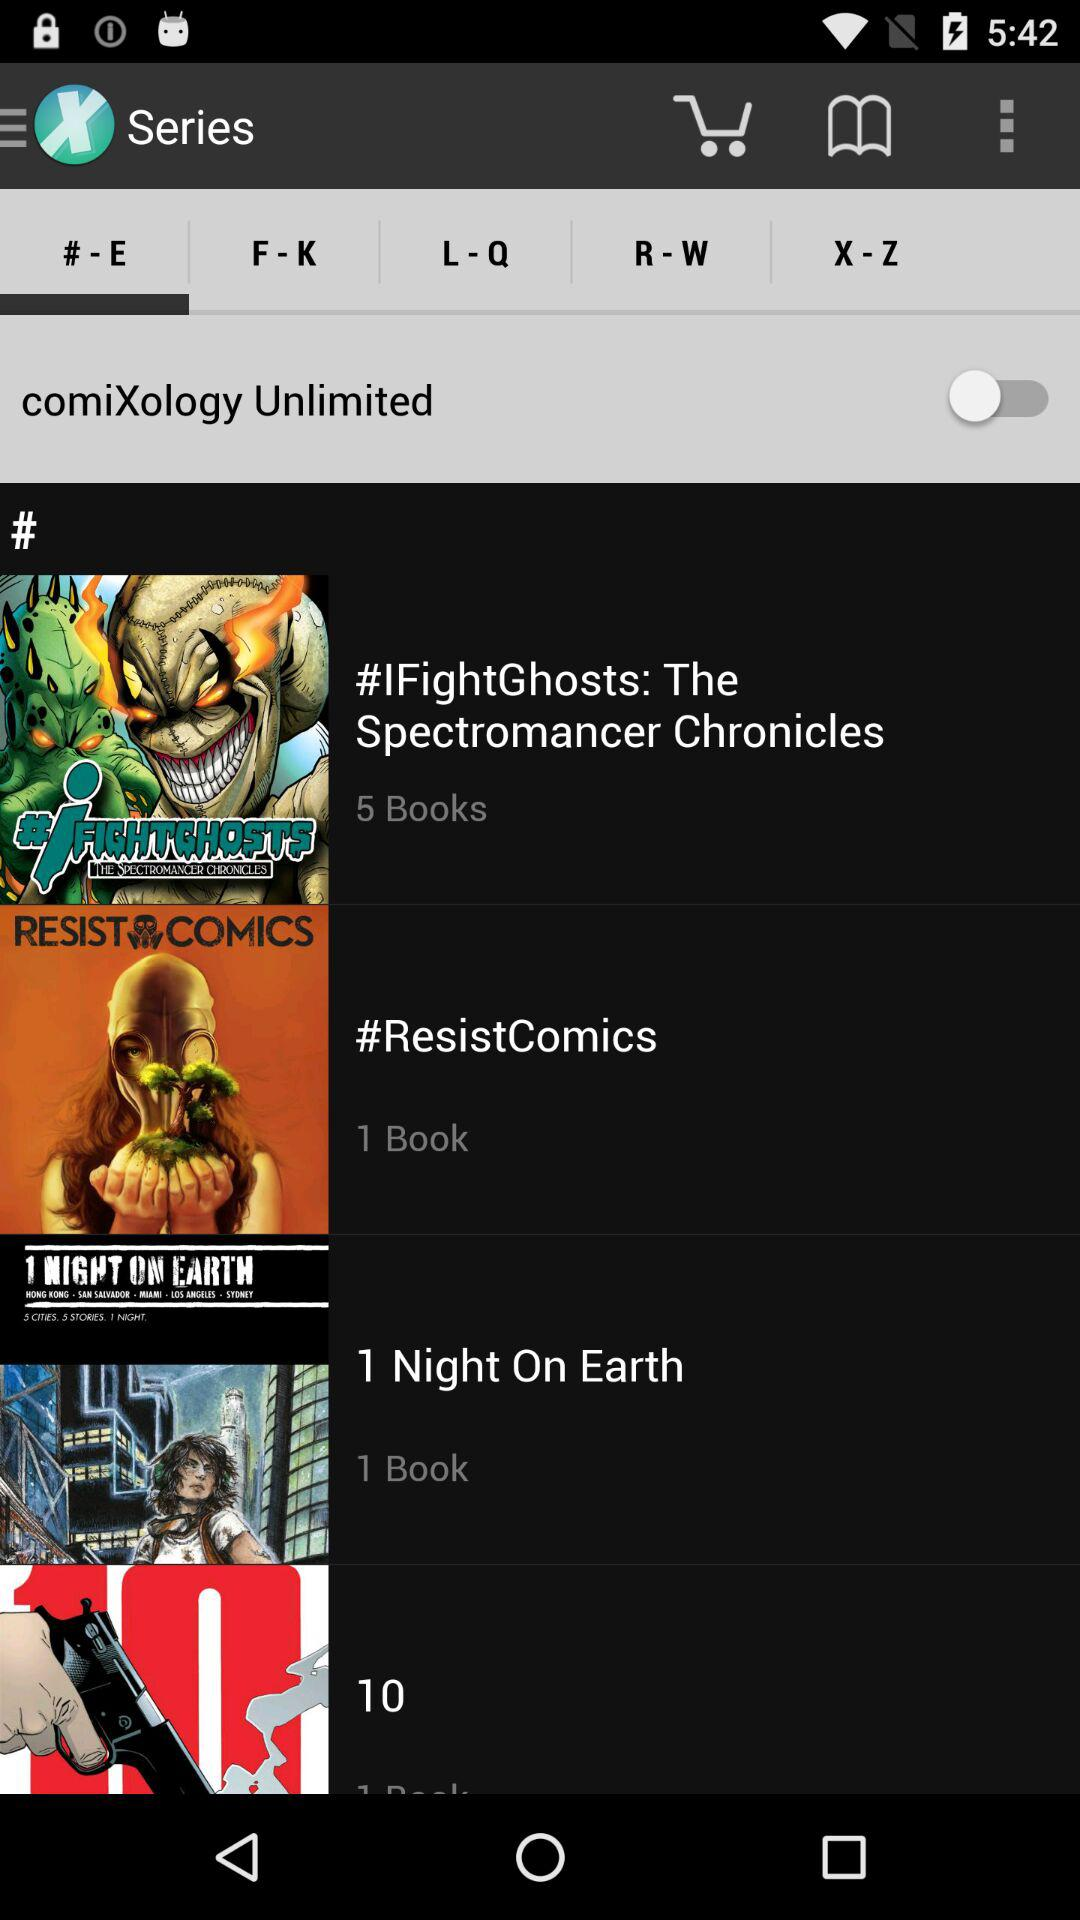How many more books are in the series with the most books than the series with the fewest books?
Answer the question using a single word or phrase. 4 